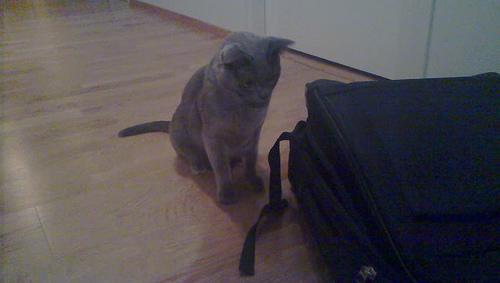What does it look like the cat wants to do?
Answer briefly. Play. Is the cat's owner going to pack or unpack the suitcase?
Give a very brief answer. Unpack. What color is the kitty?
Keep it brief. Gray. 